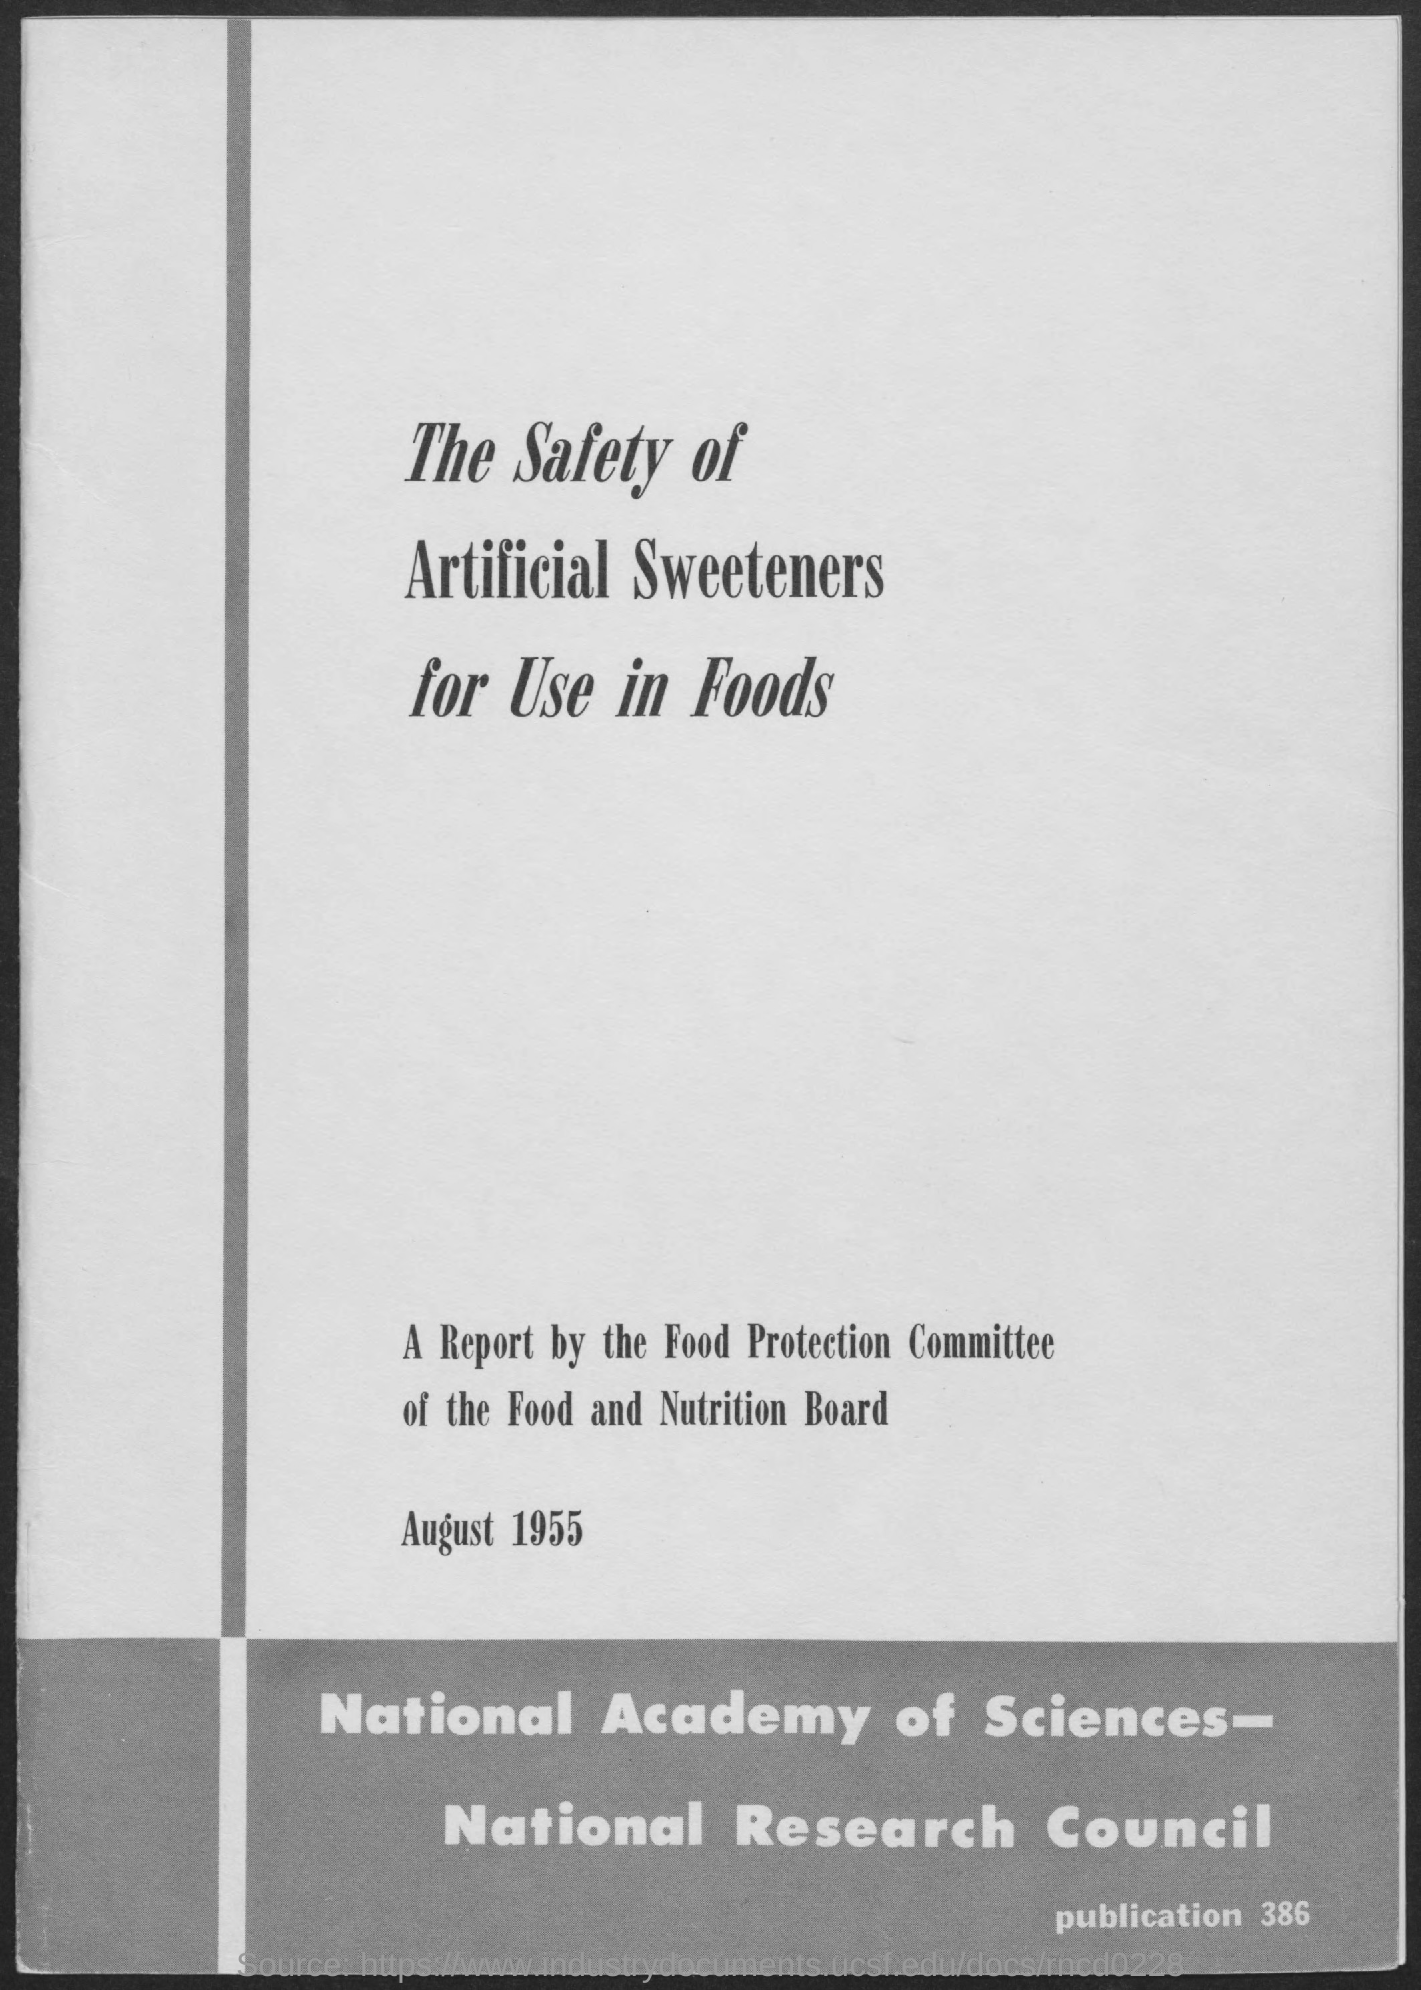Draw attention to some important aspects in this diagram. The publication number is [insert publication number]. Publication [insert publication number] provides [insert relevant information about the publication, such as its purpose or key topics covered]. The date on the document is August 1955. 